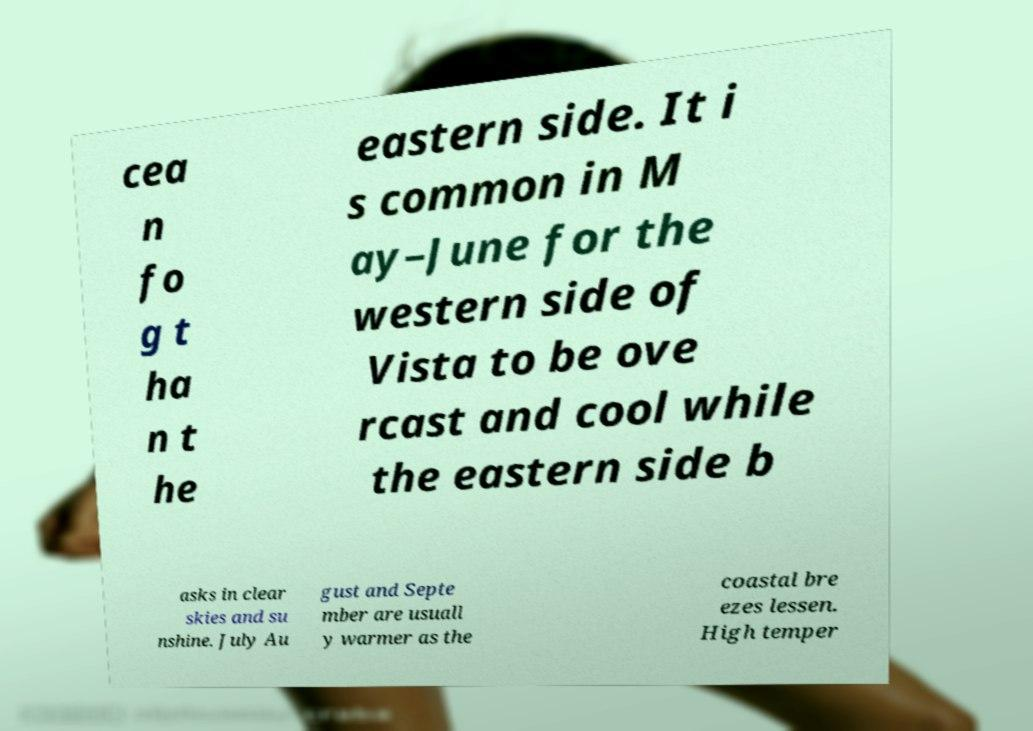For documentation purposes, I need the text within this image transcribed. Could you provide that? cea n fo g t ha n t he eastern side. It i s common in M ay–June for the western side of Vista to be ove rcast and cool while the eastern side b asks in clear skies and su nshine. July Au gust and Septe mber are usuall y warmer as the coastal bre ezes lessen. High temper 